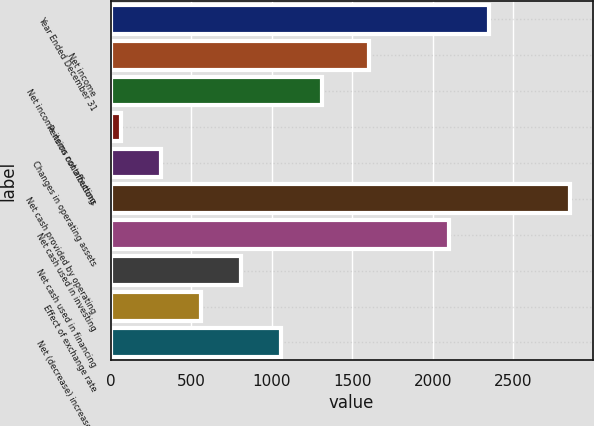Convert chart. <chart><loc_0><loc_0><loc_500><loc_500><bar_chart><fcel>Year Ended December 31<fcel>Net income<fcel>Net income items not affecting<fcel>Pension contributions<fcel>Changes in operating assets<fcel>Net cash provided by operating<fcel>Net cash used in investing<fcel>Net cash used in financing<fcel>Effect of exchange rate<fcel>Net (decrease) increase in<nl><fcel>2351.93<fcel>1604<fcel>1309.45<fcel>62.9<fcel>312.21<fcel>2850.55<fcel>2102.62<fcel>810.83<fcel>561.52<fcel>1060.14<nl></chart> 